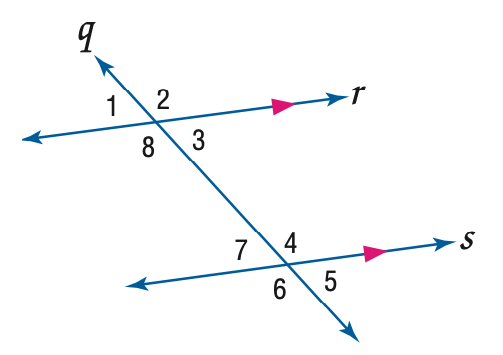Question: Use the figure to find the indicated variable. If m \angle 4 = 2 x - 17 and m \angle 1 = 85, find x.
Choices:
A. 51
B. 56
C. 61
D. 85
Answer with the letter. Answer: B 